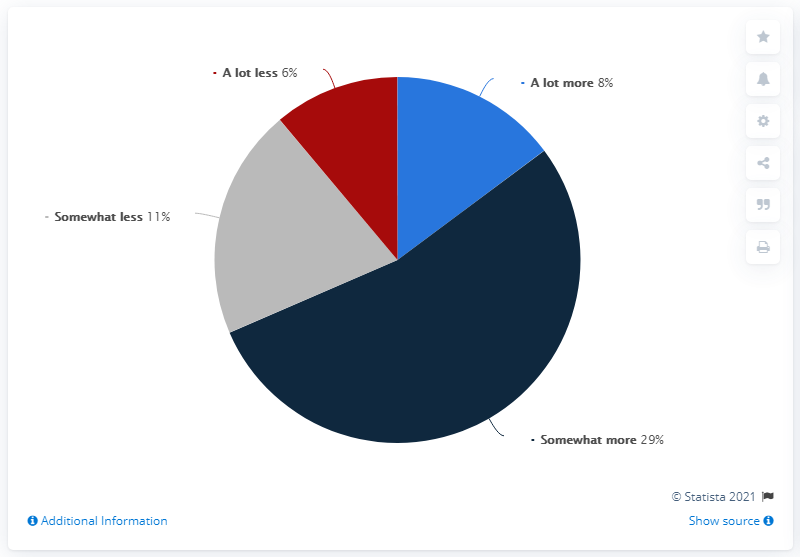Draw attention to some important aspects in this diagram. What is the most widely accepted answer? It is somewhat higher than average. The sum of negative responses is 17. 